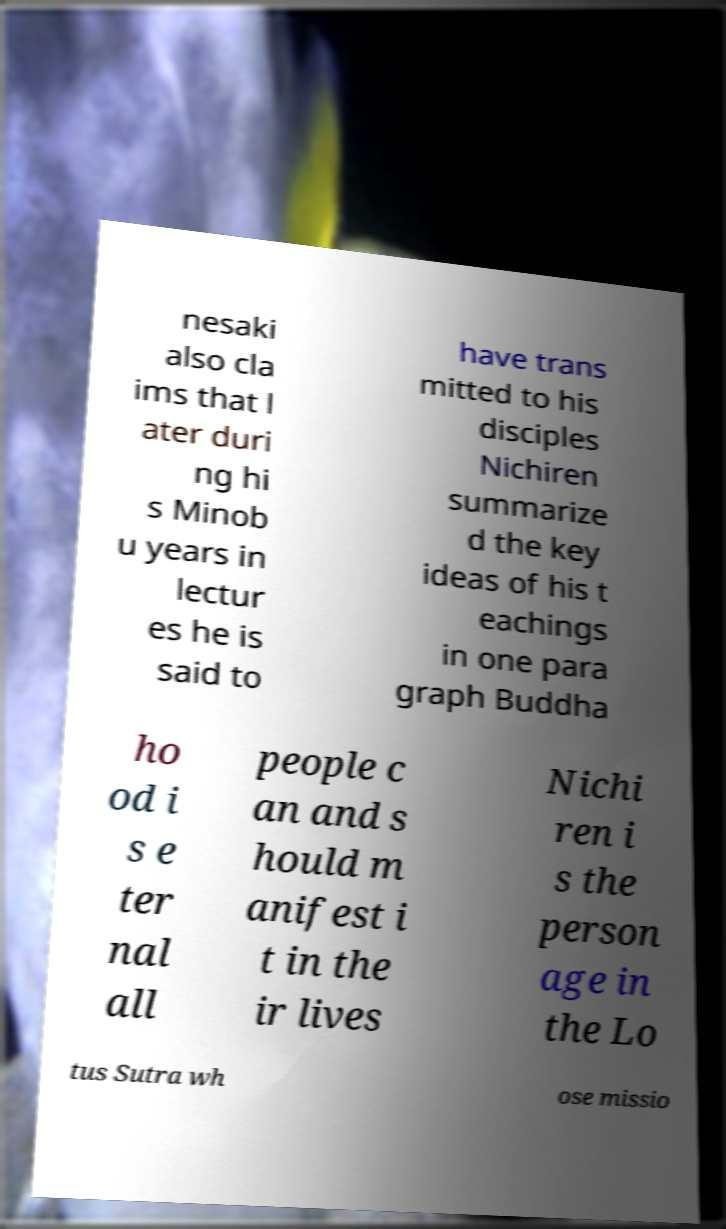What messages or text are displayed in this image? I need them in a readable, typed format. nesaki also cla ims that l ater duri ng hi s Minob u years in lectur es he is said to have trans mitted to his disciples Nichiren summarize d the key ideas of his t eachings in one para graph Buddha ho od i s e ter nal all people c an and s hould m anifest i t in the ir lives Nichi ren i s the person age in the Lo tus Sutra wh ose missio 